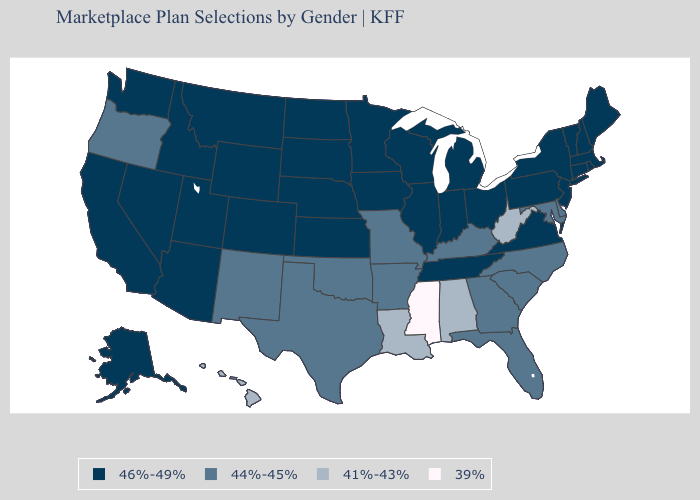Name the states that have a value in the range 46%-49%?
Answer briefly. Alaska, Arizona, California, Colorado, Connecticut, Idaho, Illinois, Indiana, Iowa, Kansas, Maine, Massachusetts, Michigan, Minnesota, Montana, Nebraska, Nevada, New Hampshire, New Jersey, New York, North Dakota, Ohio, Pennsylvania, Rhode Island, South Dakota, Tennessee, Utah, Vermont, Virginia, Washington, Wisconsin, Wyoming. Among the states that border Kentucky , which have the highest value?
Write a very short answer. Illinois, Indiana, Ohio, Tennessee, Virginia. Does Delaware have a higher value than Louisiana?
Write a very short answer. Yes. Name the states that have a value in the range 46%-49%?
Short answer required. Alaska, Arizona, California, Colorado, Connecticut, Idaho, Illinois, Indiana, Iowa, Kansas, Maine, Massachusetts, Michigan, Minnesota, Montana, Nebraska, Nevada, New Hampshire, New Jersey, New York, North Dakota, Ohio, Pennsylvania, Rhode Island, South Dakota, Tennessee, Utah, Vermont, Virginia, Washington, Wisconsin, Wyoming. Does Kentucky have a higher value than Alabama?
Keep it brief. Yes. What is the value of Wisconsin?
Short answer required. 46%-49%. Does California have the highest value in the West?
Write a very short answer. Yes. Which states have the highest value in the USA?
Keep it brief. Alaska, Arizona, California, Colorado, Connecticut, Idaho, Illinois, Indiana, Iowa, Kansas, Maine, Massachusetts, Michigan, Minnesota, Montana, Nebraska, Nevada, New Hampshire, New Jersey, New York, North Dakota, Ohio, Pennsylvania, Rhode Island, South Dakota, Tennessee, Utah, Vermont, Virginia, Washington, Wisconsin, Wyoming. Name the states that have a value in the range 44%-45%?
Concise answer only. Arkansas, Delaware, Florida, Georgia, Kentucky, Maryland, Missouri, New Mexico, North Carolina, Oklahoma, Oregon, South Carolina, Texas. Is the legend a continuous bar?
Give a very brief answer. No. How many symbols are there in the legend?
Short answer required. 4. What is the lowest value in states that border Pennsylvania?
Write a very short answer. 41%-43%. What is the value of Connecticut?
Write a very short answer. 46%-49%. Name the states that have a value in the range 39%?
Quick response, please. Mississippi. Among the states that border Idaho , does Oregon have the lowest value?
Quick response, please. Yes. 